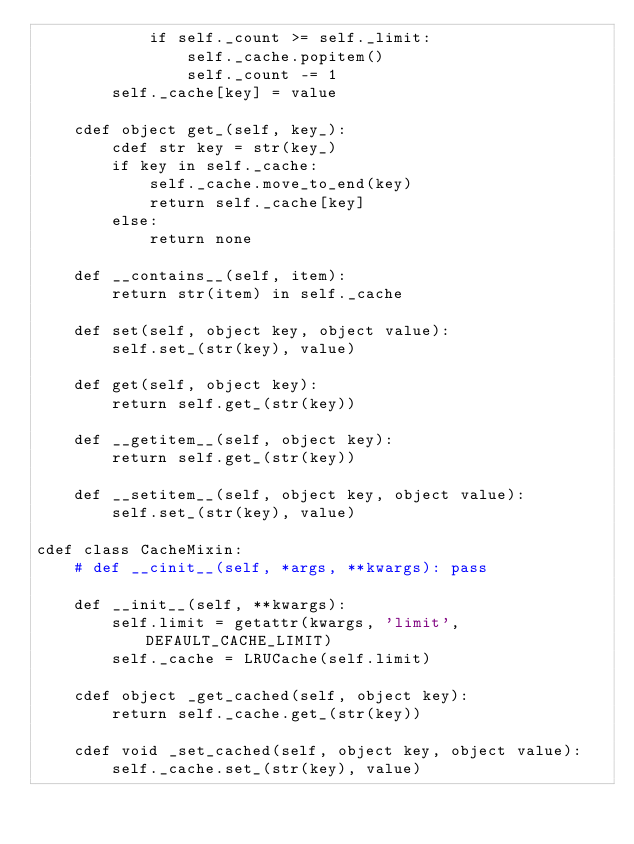Convert code to text. <code><loc_0><loc_0><loc_500><loc_500><_Cython_>            if self._count >= self._limit:
                self._cache.popitem()
                self._count -= 1
        self._cache[key] = value

    cdef object get_(self, key_):
        cdef str key = str(key_)
        if key in self._cache:
            self._cache.move_to_end(key)
            return self._cache[key]
        else:
            return none

    def __contains__(self, item):
        return str(item) in self._cache

    def set(self, object key, object value):
        self.set_(str(key), value)

    def get(self, object key):
        return self.get_(str(key))

    def __getitem__(self, object key):
        return self.get_(str(key))

    def __setitem__(self, object key, object value):
        self.set_(str(key), value)

cdef class CacheMixin:
    # def __cinit__(self, *args, **kwargs): pass

    def __init__(self, **kwargs):
        self.limit = getattr(kwargs, 'limit', DEFAULT_CACHE_LIMIT)
        self._cache = LRUCache(self.limit)

    cdef object _get_cached(self, object key):
        return self._cache.get_(str(key))

    cdef void _set_cached(self, object key, object value):
        self._cache.set_(str(key), value)</code> 